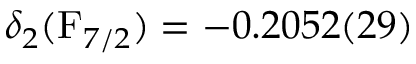Convert formula to latex. <formula><loc_0><loc_0><loc_500><loc_500>\delta _ { 2 } ( F _ { 7 / 2 } ) = - 0 . 2 0 5 2 ( 2 9 )</formula> 